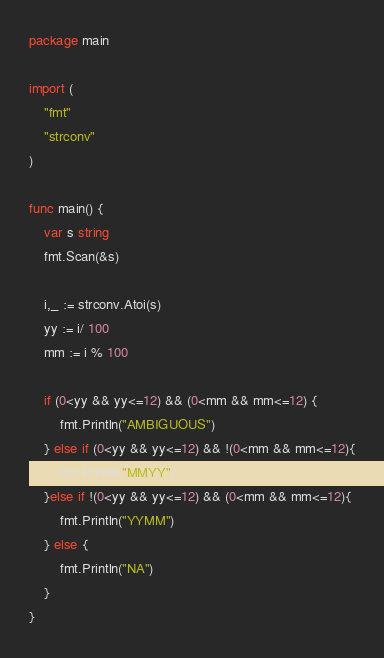Convert code to text. <code><loc_0><loc_0><loc_500><loc_500><_Go_>package main

import (
	"fmt"
	"strconv"
)

func main() {
	var s string
	fmt.Scan(&s)

	i,_ := strconv.Atoi(s)
	yy := i/ 100
	mm := i % 100

	if (0<yy && yy<=12) && (0<mm && mm<=12) {
		fmt.Println("AMBIGUOUS")
	} else if (0<yy && yy<=12) && !(0<mm && mm<=12){
		fmt.Println("MMYY")
	}else if !(0<yy && yy<=12) && (0<mm && mm<=12){
		fmt.Println("YYMM")
	} else {
		fmt.Println("NA")
	}
}
</code> 